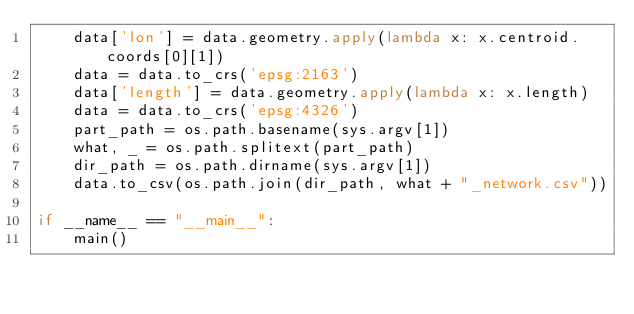<code> <loc_0><loc_0><loc_500><loc_500><_Python_>    data['lon'] = data.geometry.apply(lambda x: x.centroid.coords[0][1])
    data = data.to_crs('epsg:2163')
    data['length'] = data.geometry.apply(lambda x: x.length)
    data = data.to_crs('epsg:4326')
    part_path = os.path.basename(sys.argv[1])
    what, _ = os.path.splitext(part_path)
    dir_path = os.path.dirname(sys.argv[1])
    data.to_csv(os.path.join(dir_path, what + "_network.csv"))

if __name__ == "__main__":
    main()
</code> 